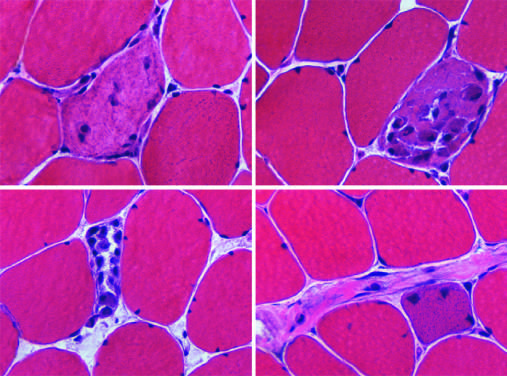what are infiltrated by variable numbers of inflammatory cells?
Answer the question using a single word or phrase. Necrotic cells 